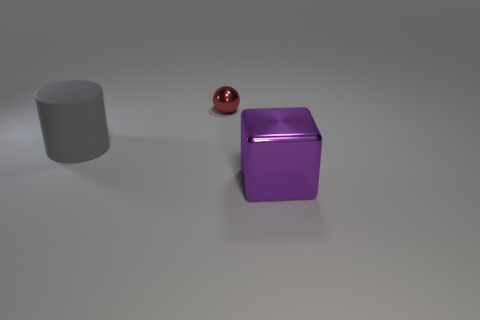Subtract all cylinders. How many objects are left? 2 Subtract 1 cylinders. How many cylinders are left? 0 Subtract all yellow spheres. Subtract all gray cylinders. How many spheres are left? 1 Subtract all big green rubber cylinders. Subtract all small metallic spheres. How many objects are left? 2 Add 2 tiny metallic spheres. How many tiny metallic spheres are left? 3 Add 1 red matte objects. How many red matte objects exist? 1 Add 2 large metal things. How many objects exist? 5 Subtract 0 cyan blocks. How many objects are left? 3 